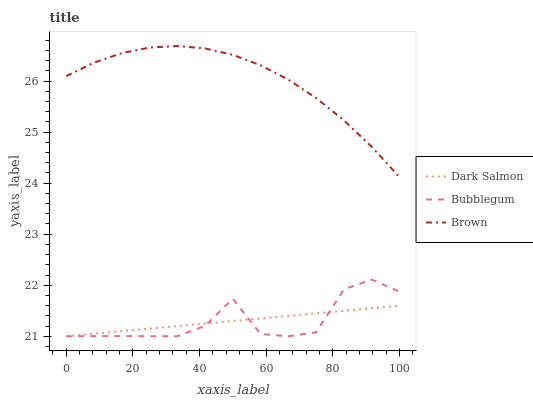Does Bubblegum have the minimum area under the curve?
Answer yes or no. Yes. Does Brown have the maximum area under the curve?
Answer yes or no. Yes. Does Dark Salmon have the minimum area under the curve?
Answer yes or no. No. Does Dark Salmon have the maximum area under the curve?
Answer yes or no. No. Is Dark Salmon the smoothest?
Answer yes or no. Yes. Is Bubblegum the roughest?
Answer yes or no. Yes. Is Bubblegum the smoothest?
Answer yes or no. No. Is Dark Salmon the roughest?
Answer yes or no. No. Does Dark Salmon have the lowest value?
Answer yes or no. Yes. Does Brown have the highest value?
Answer yes or no. Yes. Does Bubblegum have the highest value?
Answer yes or no. No. Is Bubblegum less than Brown?
Answer yes or no. Yes. Is Brown greater than Bubblegum?
Answer yes or no. Yes. Does Bubblegum intersect Dark Salmon?
Answer yes or no. Yes. Is Bubblegum less than Dark Salmon?
Answer yes or no. No. Is Bubblegum greater than Dark Salmon?
Answer yes or no. No. Does Bubblegum intersect Brown?
Answer yes or no. No. 